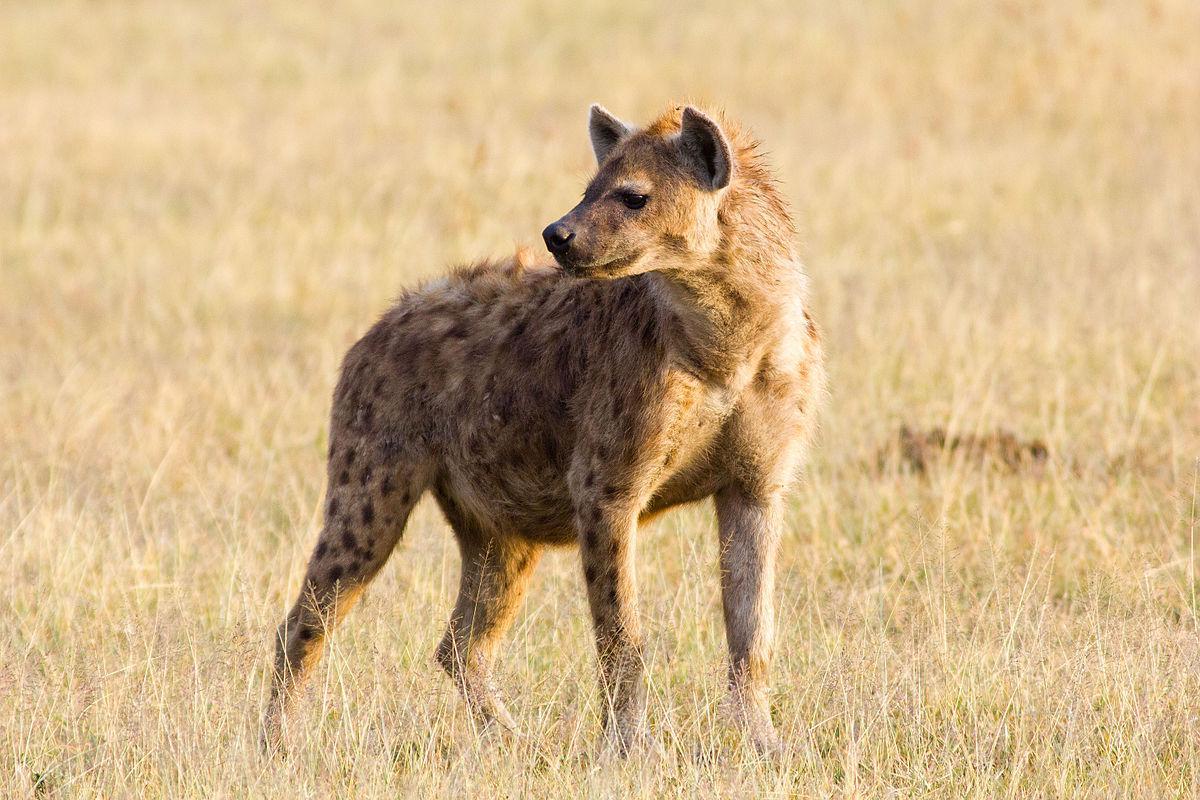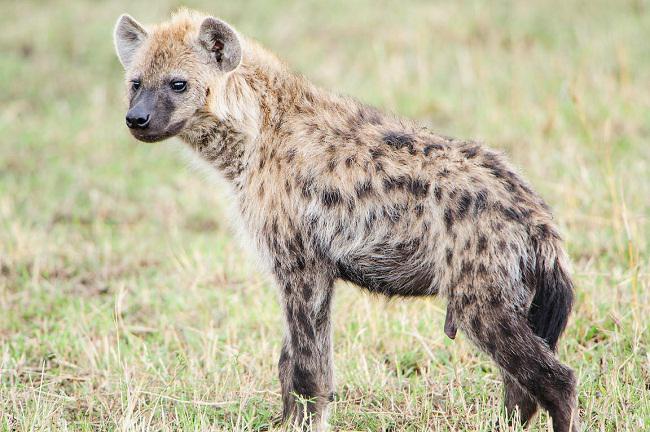The first image is the image on the left, the second image is the image on the right. For the images shown, is this caption "The hyena on the right image is facing left." true? Answer yes or no. Yes. 